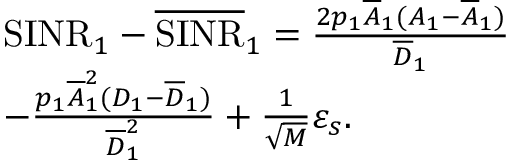<formula> <loc_0><loc_0><loc_500><loc_500>\begin{array} { r l } & { S I N R _ { 1 } - \overline { S I N R } _ { 1 } = \frac { 2 p _ { 1 } \overline { A } _ { 1 } ( A _ { 1 } - \overline { A } _ { 1 } ) } { \overline { D } _ { 1 } } } \\ & { - \frac { p _ { 1 } \overline { A } _ { 1 } ^ { 2 } ( D _ { 1 } - \overline { D } _ { 1 } ) } { \overline { D } _ { 1 } ^ { 2 } } + \frac { 1 } { \sqrt { M } } \varepsilon _ { s } . } \end{array}</formula> 